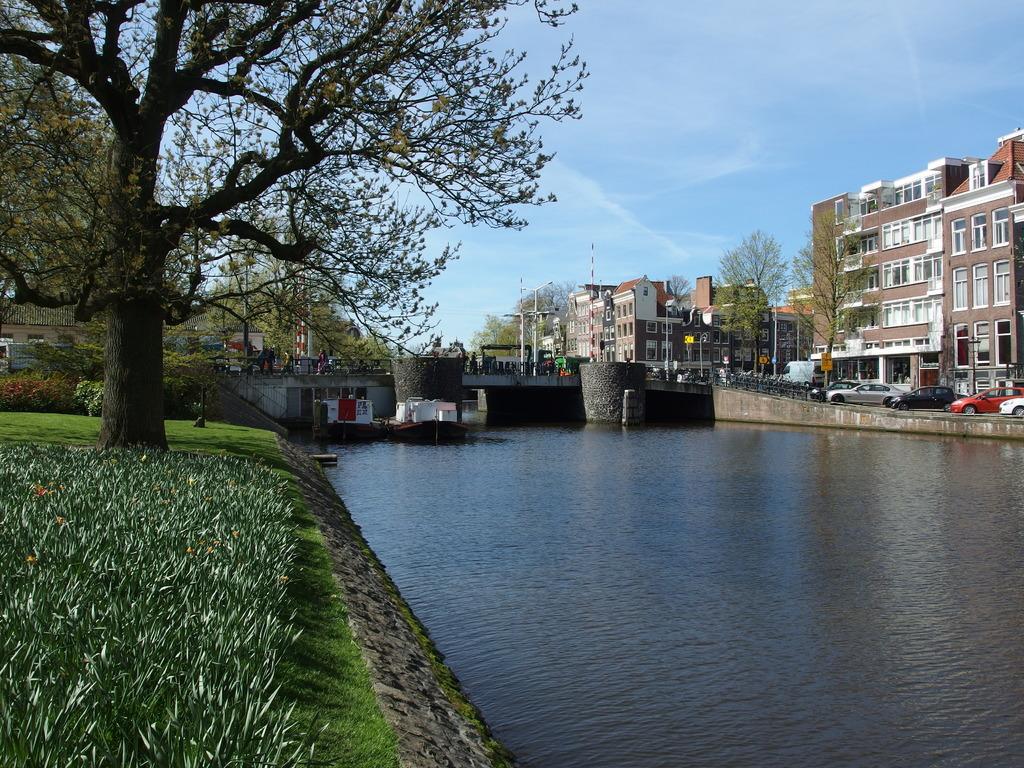Describe this image in one or two sentences. As we can see in the image there is grass, water, bridge and at the top there is sky. There are buildings, vehicles, trees, current poles and plants. 